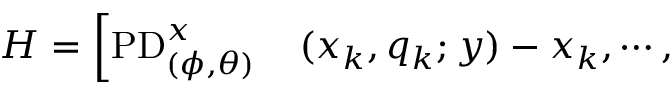Convert formula to latex. <formula><loc_0><loc_0><loc_500><loc_500>\begin{array} { r l } { H = \left [ P D _ { ( \phi , \theta ) } ^ { x } } & ( x _ { k } , q _ { k } ; y ) - x _ { k } , \cdots , } \end{array}</formula> 